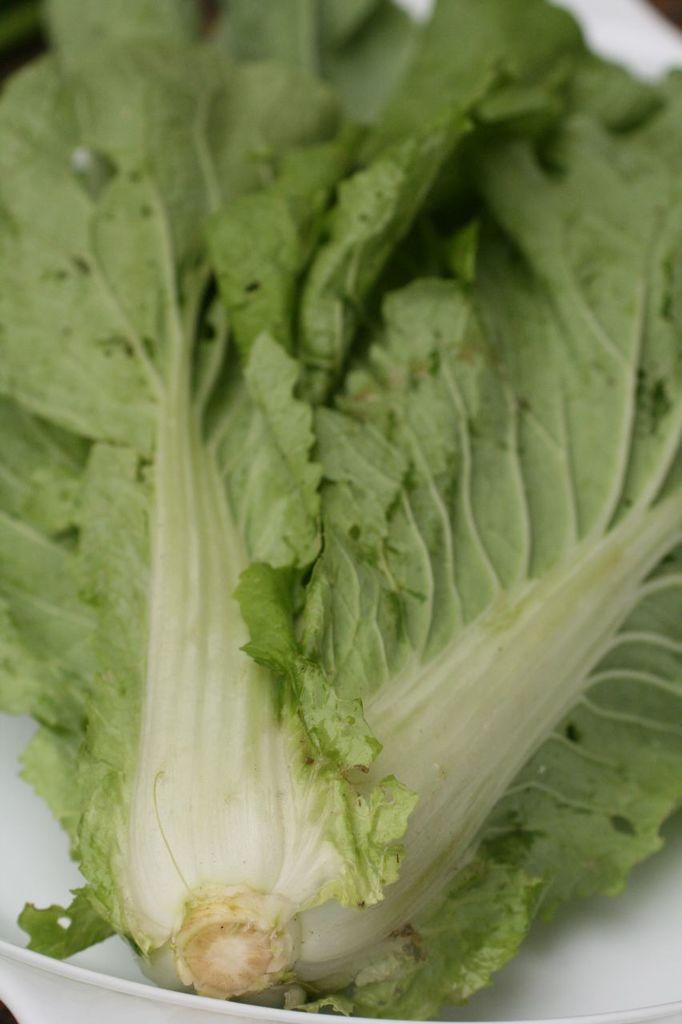Could you give a brief overview of what you see in this image? In the picture we can see a part of vegetable in the plate. 